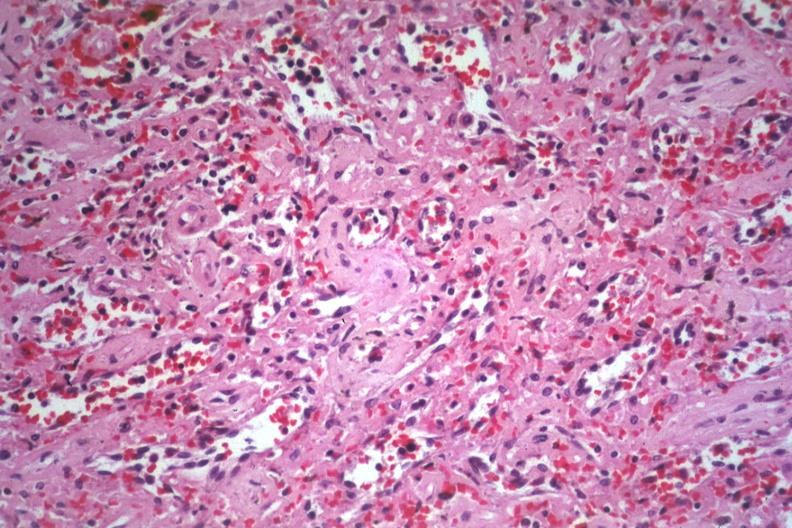what is present?
Answer the question using a single word or phrase. Amyloidosis 